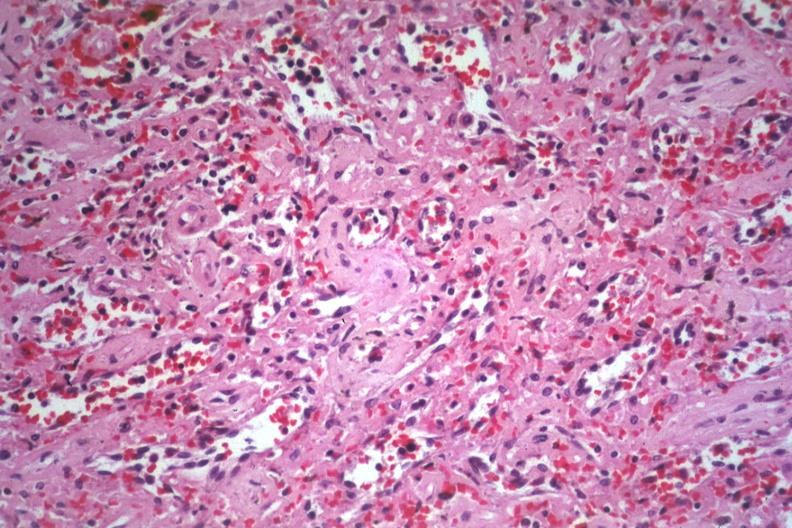what is present?
Answer the question using a single word or phrase. Amyloidosis 